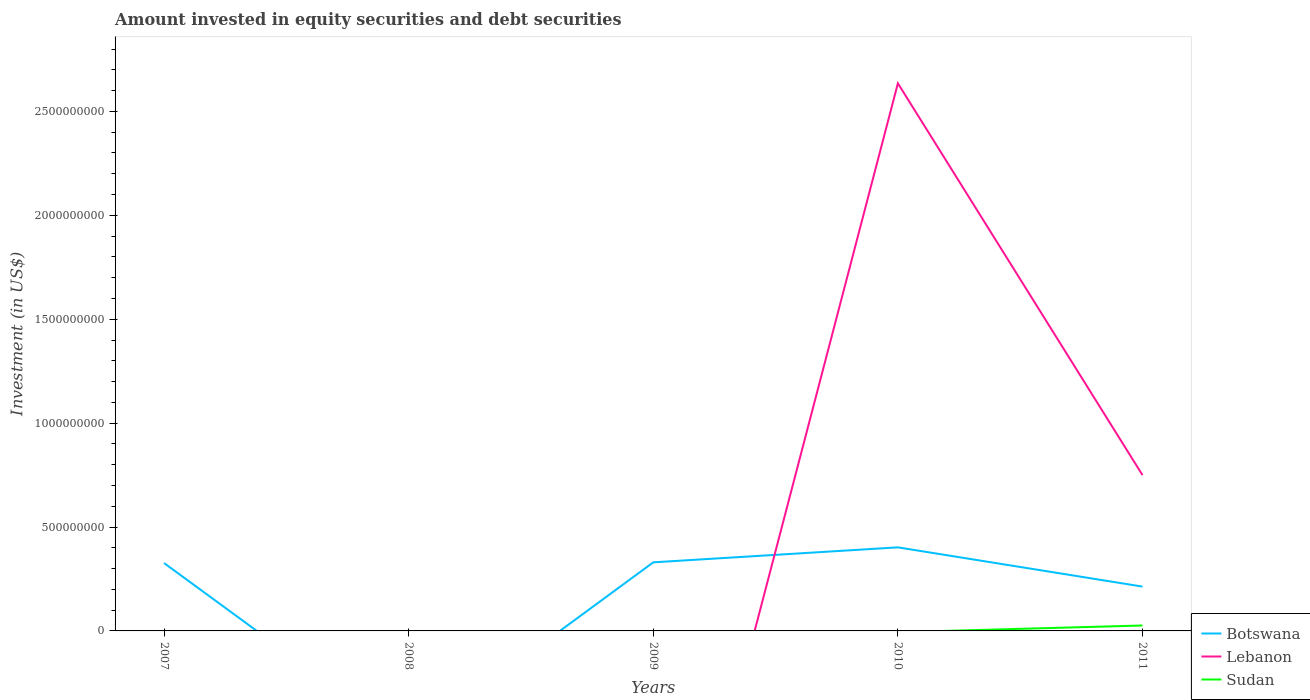How many different coloured lines are there?
Your answer should be very brief. 3. Across all years, what is the maximum amount invested in equity securities and debt securities in Botswana?
Your answer should be compact. 0. What is the total amount invested in equity securities and debt securities in Botswana in the graph?
Make the answer very short. -7.21e+07. What is the difference between the highest and the second highest amount invested in equity securities and debt securities in Lebanon?
Give a very brief answer. 2.64e+09. Does the graph contain grids?
Your answer should be very brief. No. How are the legend labels stacked?
Your answer should be compact. Vertical. What is the title of the graph?
Your answer should be very brief. Amount invested in equity securities and debt securities. Does "Sri Lanka" appear as one of the legend labels in the graph?
Keep it short and to the point. No. What is the label or title of the Y-axis?
Keep it short and to the point. Investment (in US$). What is the Investment (in US$) in Botswana in 2007?
Your answer should be very brief. 3.26e+08. What is the Investment (in US$) of Botswana in 2008?
Offer a terse response. 0. What is the Investment (in US$) of Botswana in 2009?
Ensure brevity in your answer.  3.30e+08. What is the Investment (in US$) of Sudan in 2009?
Give a very brief answer. 0. What is the Investment (in US$) in Botswana in 2010?
Keep it short and to the point. 4.02e+08. What is the Investment (in US$) in Lebanon in 2010?
Keep it short and to the point. 2.64e+09. What is the Investment (in US$) of Botswana in 2011?
Your answer should be very brief. 2.13e+08. What is the Investment (in US$) of Lebanon in 2011?
Keep it short and to the point. 7.50e+08. What is the Investment (in US$) in Sudan in 2011?
Ensure brevity in your answer.  2.61e+07. Across all years, what is the maximum Investment (in US$) of Botswana?
Provide a succinct answer. 4.02e+08. Across all years, what is the maximum Investment (in US$) in Lebanon?
Give a very brief answer. 2.64e+09. Across all years, what is the maximum Investment (in US$) of Sudan?
Provide a short and direct response. 2.61e+07. Across all years, what is the minimum Investment (in US$) in Sudan?
Your response must be concise. 0. What is the total Investment (in US$) of Botswana in the graph?
Your response must be concise. 1.27e+09. What is the total Investment (in US$) of Lebanon in the graph?
Give a very brief answer. 3.39e+09. What is the total Investment (in US$) of Sudan in the graph?
Your answer should be compact. 2.61e+07. What is the difference between the Investment (in US$) of Botswana in 2007 and that in 2009?
Offer a very short reply. -3.62e+06. What is the difference between the Investment (in US$) of Botswana in 2007 and that in 2010?
Ensure brevity in your answer.  -7.57e+07. What is the difference between the Investment (in US$) in Botswana in 2007 and that in 2011?
Provide a short and direct response. 1.13e+08. What is the difference between the Investment (in US$) in Botswana in 2009 and that in 2010?
Ensure brevity in your answer.  -7.21e+07. What is the difference between the Investment (in US$) of Botswana in 2009 and that in 2011?
Provide a short and direct response. 1.17e+08. What is the difference between the Investment (in US$) of Botswana in 2010 and that in 2011?
Your answer should be very brief. 1.89e+08. What is the difference between the Investment (in US$) of Lebanon in 2010 and that in 2011?
Give a very brief answer. 1.89e+09. What is the difference between the Investment (in US$) of Botswana in 2007 and the Investment (in US$) of Lebanon in 2010?
Ensure brevity in your answer.  -2.31e+09. What is the difference between the Investment (in US$) in Botswana in 2007 and the Investment (in US$) in Lebanon in 2011?
Your answer should be very brief. -4.24e+08. What is the difference between the Investment (in US$) of Botswana in 2007 and the Investment (in US$) of Sudan in 2011?
Offer a very short reply. 3.00e+08. What is the difference between the Investment (in US$) of Botswana in 2009 and the Investment (in US$) of Lebanon in 2010?
Ensure brevity in your answer.  -2.31e+09. What is the difference between the Investment (in US$) in Botswana in 2009 and the Investment (in US$) in Lebanon in 2011?
Ensure brevity in your answer.  -4.20e+08. What is the difference between the Investment (in US$) of Botswana in 2009 and the Investment (in US$) of Sudan in 2011?
Ensure brevity in your answer.  3.04e+08. What is the difference between the Investment (in US$) in Botswana in 2010 and the Investment (in US$) in Lebanon in 2011?
Keep it short and to the point. -3.48e+08. What is the difference between the Investment (in US$) in Botswana in 2010 and the Investment (in US$) in Sudan in 2011?
Your answer should be compact. 3.76e+08. What is the difference between the Investment (in US$) of Lebanon in 2010 and the Investment (in US$) of Sudan in 2011?
Keep it short and to the point. 2.61e+09. What is the average Investment (in US$) in Botswana per year?
Provide a short and direct response. 2.54e+08. What is the average Investment (in US$) of Lebanon per year?
Provide a short and direct response. 6.77e+08. What is the average Investment (in US$) of Sudan per year?
Keep it short and to the point. 5.22e+06. In the year 2010, what is the difference between the Investment (in US$) of Botswana and Investment (in US$) of Lebanon?
Keep it short and to the point. -2.23e+09. In the year 2011, what is the difference between the Investment (in US$) in Botswana and Investment (in US$) in Lebanon?
Make the answer very short. -5.37e+08. In the year 2011, what is the difference between the Investment (in US$) of Botswana and Investment (in US$) of Sudan?
Give a very brief answer. 1.87e+08. In the year 2011, what is the difference between the Investment (in US$) in Lebanon and Investment (in US$) in Sudan?
Your answer should be very brief. 7.24e+08. What is the ratio of the Investment (in US$) in Botswana in 2007 to that in 2010?
Make the answer very short. 0.81. What is the ratio of the Investment (in US$) in Botswana in 2007 to that in 2011?
Offer a terse response. 1.53. What is the ratio of the Investment (in US$) in Botswana in 2009 to that in 2010?
Keep it short and to the point. 0.82. What is the ratio of the Investment (in US$) of Botswana in 2009 to that in 2011?
Provide a short and direct response. 1.55. What is the ratio of the Investment (in US$) of Botswana in 2010 to that in 2011?
Provide a short and direct response. 1.89. What is the ratio of the Investment (in US$) of Lebanon in 2010 to that in 2011?
Offer a terse response. 3.51. What is the difference between the highest and the second highest Investment (in US$) in Botswana?
Provide a short and direct response. 7.21e+07. What is the difference between the highest and the lowest Investment (in US$) of Botswana?
Offer a very short reply. 4.02e+08. What is the difference between the highest and the lowest Investment (in US$) of Lebanon?
Your response must be concise. 2.64e+09. What is the difference between the highest and the lowest Investment (in US$) of Sudan?
Your response must be concise. 2.61e+07. 